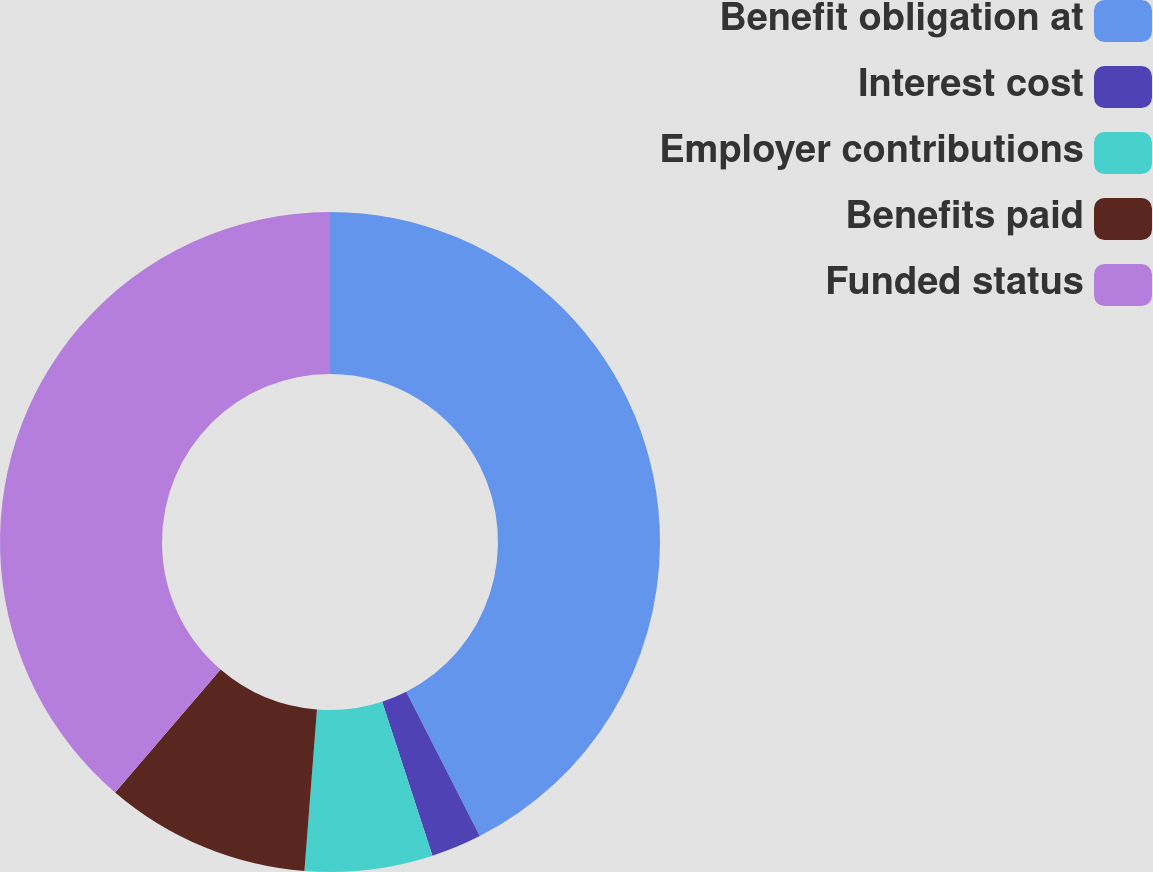Convert chart to OTSL. <chart><loc_0><loc_0><loc_500><loc_500><pie_chart><fcel>Benefit obligation at<fcel>Interest cost<fcel>Employer contributions<fcel>Benefits paid<fcel>Funded status<nl><fcel>42.5%<fcel>2.47%<fcel>6.26%<fcel>10.05%<fcel>38.71%<nl></chart> 